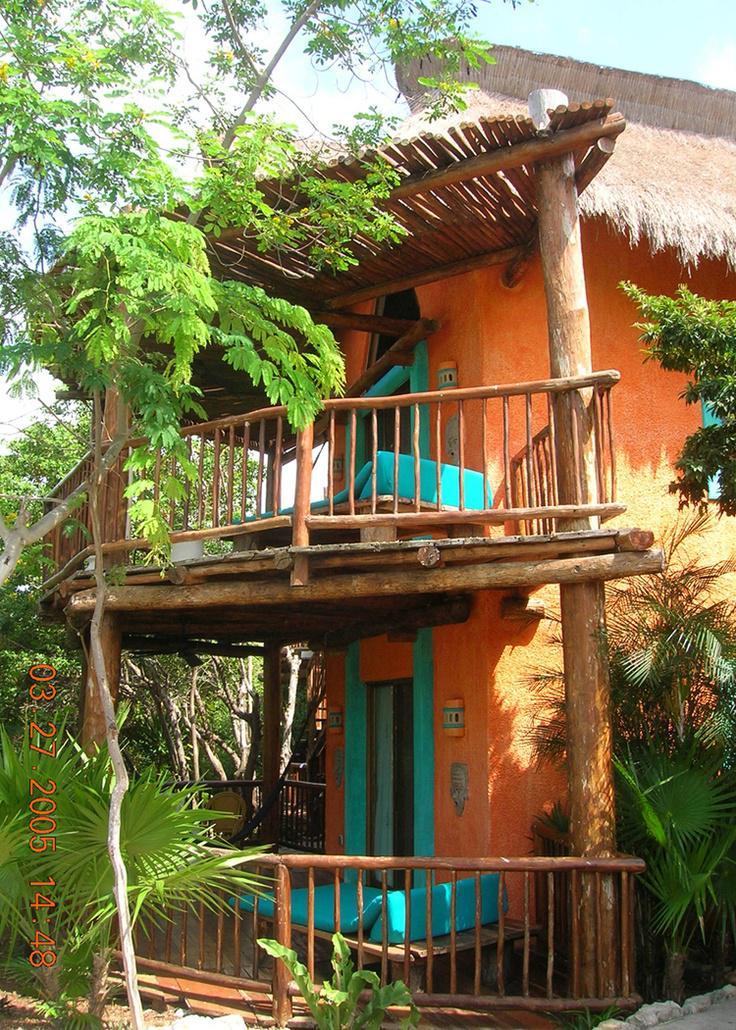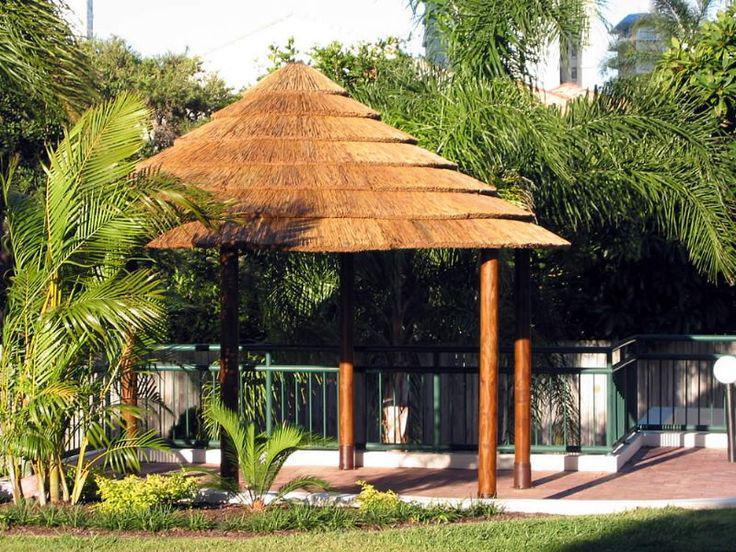The first image is the image on the left, the second image is the image on the right. For the images displayed, is the sentence "In at least one image there is a rounded small gazebo with no more than five wooden poles and is not walled up." factually correct? Answer yes or no. Yes. The first image is the image on the left, the second image is the image on the right. Analyze the images presented: Is the assertion "The combined images include a two-story structure with wood rails on it and multiple tiered round thatched roofs." valid? Answer yes or no. Yes. 